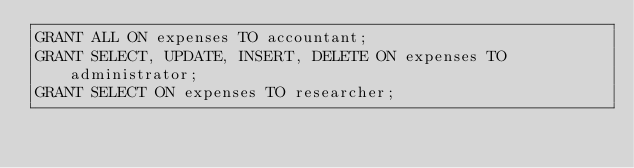Convert code to text. <code><loc_0><loc_0><loc_500><loc_500><_SQL_>GRANT ALL ON expenses TO accountant;
GRANT SELECT, UPDATE, INSERT, DELETE ON expenses TO administrator;
GRANT SELECT ON expenses TO researcher;

</code> 